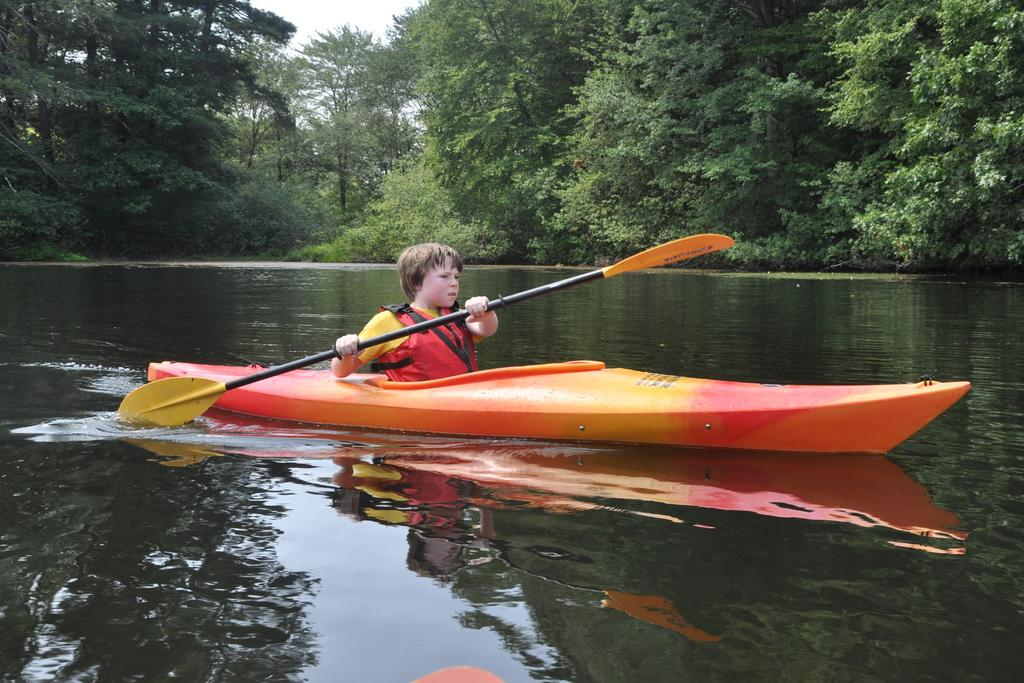What is the main subject of the image? The main subject of the image is a boat above the water. What is the person in the image doing? The person is holding a paddle in the image. What can be seen in the background of the image? There are trees visible in the background of the image. What type of respect can be seen in the veins of the person holding the paddle in the image? There is no indication of respect or veins in the image; it features a boat above the water and a person holding a paddle. 